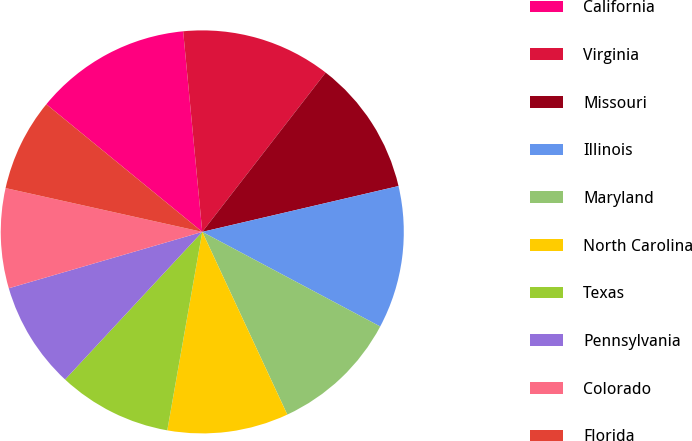<chart> <loc_0><loc_0><loc_500><loc_500><pie_chart><fcel>California<fcel>Virginia<fcel>Missouri<fcel>Illinois<fcel>Maryland<fcel>North Carolina<fcel>Texas<fcel>Pennsylvania<fcel>Colorado<fcel>Florida<nl><fcel>12.57%<fcel>12.0%<fcel>10.86%<fcel>11.43%<fcel>10.29%<fcel>9.71%<fcel>9.14%<fcel>8.57%<fcel>8.0%<fcel>7.43%<nl></chart> 